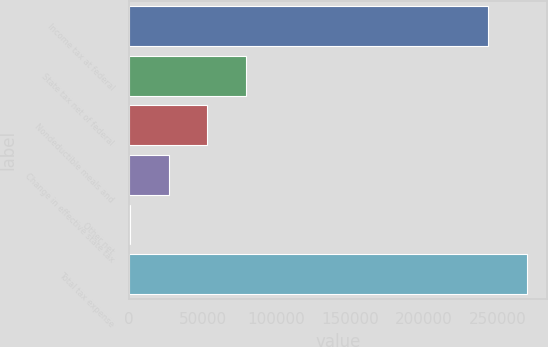<chart> <loc_0><loc_0><loc_500><loc_500><bar_chart><fcel>Income tax at federal<fcel>State tax net of federal<fcel>Nondeductible meals and<fcel>Change in effective state tax<fcel>Other net<fcel>Total tax expense<nl><fcel>243529<fcel>79566.4<fcel>53260.6<fcel>26954.8<fcel>649<fcel>269835<nl></chart> 